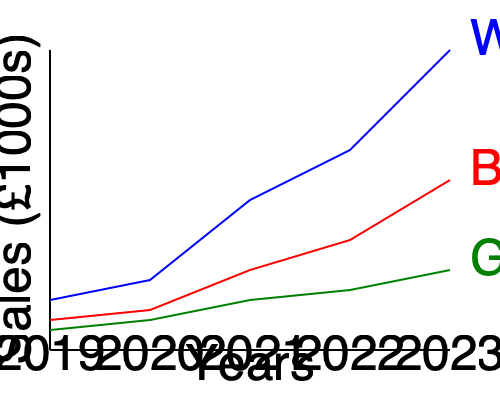As a chain store manager looking to expand in the Worcester area, you're analyzing sales growth trends across different branches. Based on the line graph showing sales performance from 2019 to 2023 for Worcester, Birmingham, and Gloucester branches, which location demonstrates the most promising growth trajectory for potential expansion? To determine the most promising growth trajectory for potential expansion, we need to analyze the sales trends for each location:

1. Worcester (Blue line):
   - Starts at around £50,000 in 2019
   - Shows consistent and steep upward trend
   - Ends at approximately £300,000 in 2023
   - Demonstrates the highest overall growth

2. Birmingham (Red line):
   - Starts at around £30,000 in 2019
   - Shows moderate but consistent growth
   - Ends at approximately £170,000 in 2023
   - Demonstrates steady growth, but less than Worcester

3. Gloucester (Green line):
   - Starts at around £20,000 in 2019
   - Shows slow but consistent growth
   - Ends at approximately £80,000 in 2023
   - Demonstrates the lowest overall growth

Calculating the approximate growth rates:

Worcester: $(300,000 - 50,000) / 50,000 \times 100\% = 500\%$ growth
Birmingham: $(170,000 - 30,000) / 30,000 \times 100\% \approx 467\%$ growth
Gloucester: $(80,000 - 20,000) / 20,000 \times 100\% = 300\%$ growth

Worcester shows the steepest upward trend, highest overall sales by 2023, and the highest growth rate of 500% over the five-year period. This indicates that the Worcester branch has the most promising growth trajectory for potential expansion.
Answer: Worcester 